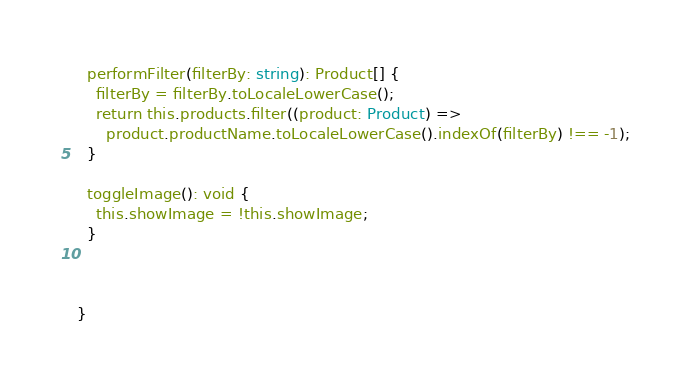<code> <loc_0><loc_0><loc_500><loc_500><_TypeScript_>
  performFilter(filterBy: string): Product[] {
    filterBy = filterBy.toLocaleLowerCase();
    return this.products.filter((product: Product) =>
      product.productName.toLocaleLowerCase().indexOf(filterBy) !== -1);
  }

  toggleImage(): void {
    this.showImage = !this.showImage;
  }



}


</code> 